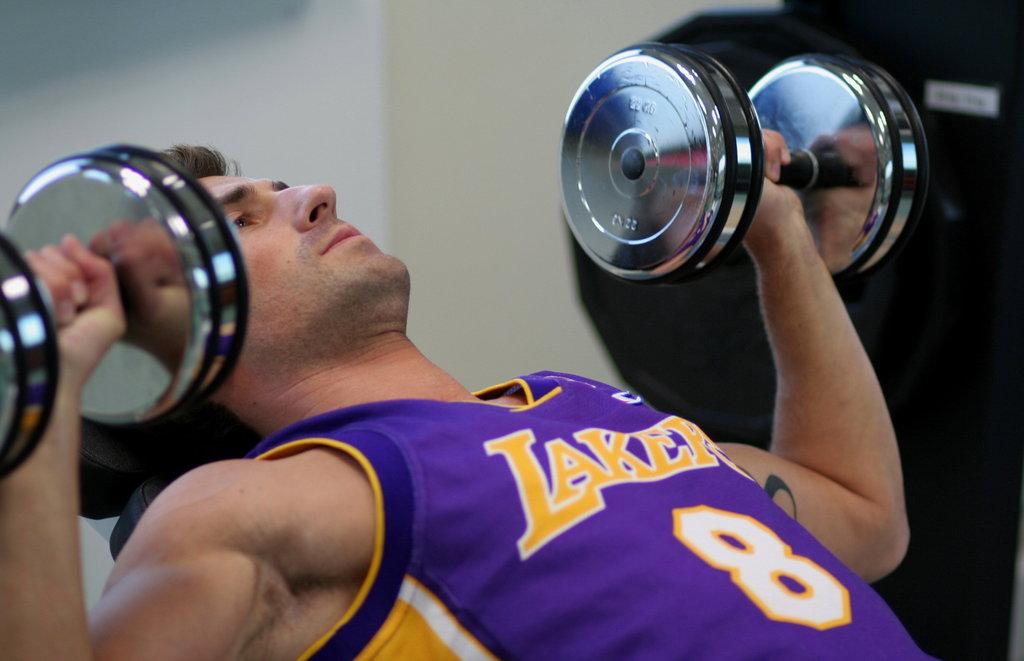Who is that player?
Give a very brief answer. 8. What number is on the jersey?
Offer a very short reply. 8. 